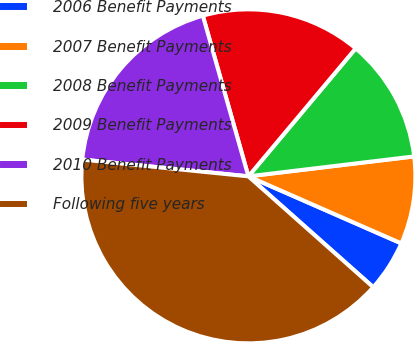Convert chart. <chart><loc_0><loc_0><loc_500><loc_500><pie_chart><fcel>2006 Benefit Payments<fcel>2007 Benefit Payments<fcel>2008 Benefit Payments<fcel>2009 Benefit Payments<fcel>2010 Benefit Payments<fcel>Following five years<nl><fcel>4.98%<fcel>8.48%<fcel>11.99%<fcel>15.5%<fcel>19.0%<fcel>40.04%<nl></chart> 